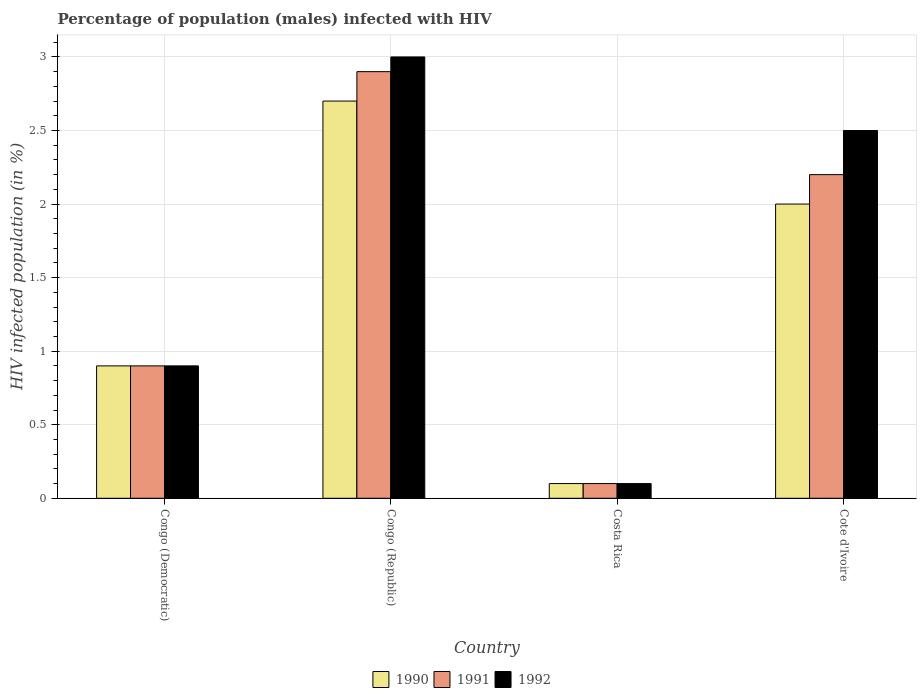How many different coloured bars are there?
Offer a very short reply. 3. Are the number of bars per tick equal to the number of legend labels?
Give a very brief answer. Yes. How many bars are there on the 1st tick from the right?
Keep it short and to the point. 3. In how many cases, is the number of bars for a given country not equal to the number of legend labels?
Your answer should be compact. 0. In which country was the percentage of HIV infected male population in 1992 maximum?
Offer a very short reply. Congo (Republic). What is the difference between the percentage of HIV infected male population in 1991 in Costa Rica and that in Cote d'Ivoire?
Offer a very short reply. -2.1. What is the average percentage of HIV infected male population in 1992 per country?
Offer a very short reply. 1.62. What is the difference between the percentage of HIV infected male population of/in 1992 and percentage of HIV infected male population of/in 1991 in Congo (Democratic)?
Offer a very short reply. 0. What is the ratio of the percentage of HIV infected male population in 1991 in Congo (Democratic) to that in Cote d'Ivoire?
Ensure brevity in your answer.  0.41. What is the difference between the highest and the second highest percentage of HIV infected male population in 1991?
Provide a succinct answer. -2. What is the difference between the highest and the lowest percentage of HIV infected male population in 1990?
Offer a very short reply. 2.6. Is the sum of the percentage of HIV infected male population in 1990 in Congo (Democratic) and Cote d'Ivoire greater than the maximum percentage of HIV infected male population in 1992 across all countries?
Ensure brevity in your answer.  No. How many bars are there?
Offer a very short reply. 12. Are all the bars in the graph horizontal?
Provide a short and direct response. No. What is the difference between two consecutive major ticks on the Y-axis?
Your answer should be very brief. 0.5. Does the graph contain any zero values?
Offer a very short reply. No. Does the graph contain grids?
Provide a succinct answer. Yes. Where does the legend appear in the graph?
Offer a terse response. Bottom center. How are the legend labels stacked?
Make the answer very short. Horizontal. What is the title of the graph?
Keep it short and to the point. Percentage of population (males) infected with HIV. What is the label or title of the X-axis?
Offer a terse response. Country. What is the label or title of the Y-axis?
Ensure brevity in your answer.  HIV infected population (in %). What is the HIV infected population (in %) of 1991 in Congo (Democratic)?
Your answer should be very brief. 0.9. What is the HIV infected population (in %) in 1990 in Congo (Republic)?
Your answer should be very brief. 2.7. What is the HIV infected population (in %) in 1991 in Congo (Republic)?
Keep it short and to the point. 2.9. What is the HIV infected population (in %) of 1992 in Congo (Republic)?
Provide a succinct answer. 3. What is the HIV infected population (in %) in 1990 in Costa Rica?
Your answer should be compact. 0.1. What is the HIV infected population (in %) of 1992 in Costa Rica?
Ensure brevity in your answer.  0.1. What is the HIV infected population (in %) in 1991 in Cote d'Ivoire?
Make the answer very short. 2.2. What is the HIV infected population (in %) in 1992 in Cote d'Ivoire?
Provide a succinct answer. 2.5. Across all countries, what is the maximum HIV infected population (in %) of 1991?
Ensure brevity in your answer.  2.9. Across all countries, what is the maximum HIV infected population (in %) of 1992?
Ensure brevity in your answer.  3. Across all countries, what is the minimum HIV infected population (in %) in 1990?
Offer a terse response. 0.1. Across all countries, what is the minimum HIV infected population (in %) of 1992?
Offer a very short reply. 0.1. What is the total HIV infected population (in %) of 1991 in the graph?
Your response must be concise. 6.1. What is the difference between the HIV infected population (in %) in 1991 in Congo (Democratic) and that in Congo (Republic)?
Provide a short and direct response. -2. What is the difference between the HIV infected population (in %) in 1991 in Congo (Democratic) and that in Costa Rica?
Ensure brevity in your answer.  0.8. What is the difference between the HIV infected population (in %) of 1991 in Congo (Democratic) and that in Cote d'Ivoire?
Your answer should be very brief. -1.3. What is the difference between the HIV infected population (in %) of 1992 in Congo (Democratic) and that in Cote d'Ivoire?
Keep it short and to the point. -1.6. What is the difference between the HIV infected population (in %) of 1990 in Congo (Republic) and that in Costa Rica?
Offer a very short reply. 2.6. What is the difference between the HIV infected population (in %) in 1990 in Congo (Republic) and that in Cote d'Ivoire?
Offer a very short reply. 0.7. What is the difference between the HIV infected population (in %) in 1991 in Congo (Republic) and that in Cote d'Ivoire?
Provide a succinct answer. 0.7. What is the difference between the HIV infected population (in %) in 1992 in Congo (Republic) and that in Cote d'Ivoire?
Provide a succinct answer. 0.5. What is the difference between the HIV infected population (in %) of 1991 in Costa Rica and that in Cote d'Ivoire?
Your answer should be very brief. -2.1. What is the difference between the HIV infected population (in %) of 1990 in Congo (Democratic) and the HIV infected population (in %) of 1992 in Congo (Republic)?
Offer a terse response. -2.1. What is the difference between the HIV infected population (in %) of 1991 in Congo (Democratic) and the HIV infected population (in %) of 1992 in Congo (Republic)?
Your response must be concise. -2.1. What is the difference between the HIV infected population (in %) of 1990 in Congo (Democratic) and the HIV infected population (in %) of 1991 in Costa Rica?
Make the answer very short. 0.8. What is the difference between the HIV infected population (in %) of 1991 in Congo (Democratic) and the HIV infected population (in %) of 1992 in Costa Rica?
Ensure brevity in your answer.  0.8. What is the difference between the HIV infected population (in %) of 1990 in Congo (Democratic) and the HIV infected population (in %) of 1992 in Cote d'Ivoire?
Offer a very short reply. -1.6. What is the difference between the HIV infected population (in %) of 1991 in Congo (Democratic) and the HIV infected population (in %) of 1992 in Cote d'Ivoire?
Your answer should be very brief. -1.6. What is the difference between the HIV infected population (in %) in 1990 in Congo (Republic) and the HIV infected population (in %) in 1991 in Costa Rica?
Offer a terse response. 2.6. What is the difference between the HIV infected population (in %) of 1990 in Congo (Republic) and the HIV infected population (in %) of 1992 in Cote d'Ivoire?
Give a very brief answer. 0.2. What is the difference between the HIV infected population (in %) of 1990 in Costa Rica and the HIV infected population (in %) of 1991 in Cote d'Ivoire?
Offer a terse response. -2.1. What is the difference between the HIV infected population (in %) of 1990 in Costa Rica and the HIV infected population (in %) of 1992 in Cote d'Ivoire?
Offer a very short reply. -2.4. What is the difference between the HIV infected population (in %) of 1991 in Costa Rica and the HIV infected population (in %) of 1992 in Cote d'Ivoire?
Offer a terse response. -2.4. What is the average HIV infected population (in %) in 1990 per country?
Offer a terse response. 1.43. What is the average HIV infected population (in %) of 1991 per country?
Give a very brief answer. 1.52. What is the average HIV infected population (in %) of 1992 per country?
Your answer should be very brief. 1.62. What is the difference between the HIV infected population (in %) in 1990 and HIV infected population (in %) in 1991 in Congo (Republic)?
Make the answer very short. -0.2. What is the difference between the HIV infected population (in %) in 1990 and HIV infected population (in %) in 1991 in Costa Rica?
Offer a very short reply. 0. What is the difference between the HIV infected population (in %) in 1990 and HIV infected population (in %) in 1992 in Costa Rica?
Offer a very short reply. 0. What is the difference between the HIV infected population (in %) of 1991 and HIV infected population (in %) of 1992 in Costa Rica?
Provide a short and direct response. 0. What is the ratio of the HIV infected population (in %) of 1991 in Congo (Democratic) to that in Congo (Republic)?
Provide a short and direct response. 0.31. What is the ratio of the HIV infected population (in %) of 1992 in Congo (Democratic) to that in Congo (Republic)?
Your response must be concise. 0.3. What is the ratio of the HIV infected population (in %) of 1990 in Congo (Democratic) to that in Costa Rica?
Provide a short and direct response. 9. What is the ratio of the HIV infected population (in %) of 1990 in Congo (Democratic) to that in Cote d'Ivoire?
Your answer should be compact. 0.45. What is the ratio of the HIV infected population (in %) in 1991 in Congo (Democratic) to that in Cote d'Ivoire?
Keep it short and to the point. 0.41. What is the ratio of the HIV infected population (in %) in 1992 in Congo (Democratic) to that in Cote d'Ivoire?
Provide a short and direct response. 0.36. What is the ratio of the HIV infected population (in %) of 1990 in Congo (Republic) to that in Costa Rica?
Give a very brief answer. 27. What is the ratio of the HIV infected population (in %) of 1992 in Congo (Republic) to that in Costa Rica?
Provide a succinct answer. 30. What is the ratio of the HIV infected population (in %) in 1990 in Congo (Republic) to that in Cote d'Ivoire?
Provide a short and direct response. 1.35. What is the ratio of the HIV infected population (in %) in 1991 in Congo (Republic) to that in Cote d'Ivoire?
Make the answer very short. 1.32. What is the ratio of the HIV infected population (in %) of 1992 in Congo (Republic) to that in Cote d'Ivoire?
Your answer should be compact. 1.2. What is the ratio of the HIV infected population (in %) of 1991 in Costa Rica to that in Cote d'Ivoire?
Offer a very short reply. 0.05. What is the difference between the highest and the second highest HIV infected population (in %) in 1991?
Ensure brevity in your answer.  0.7. What is the difference between the highest and the lowest HIV infected population (in %) of 1990?
Provide a short and direct response. 2.6. What is the difference between the highest and the lowest HIV infected population (in %) of 1991?
Your answer should be compact. 2.8. 